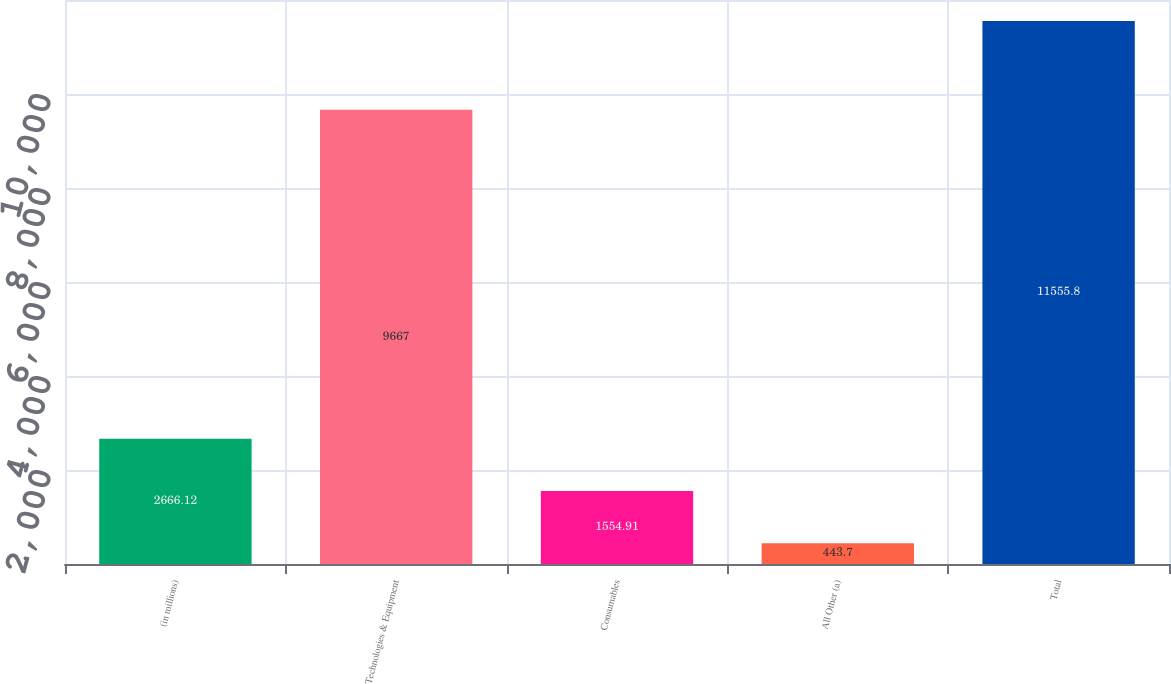<chart> <loc_0><loc_0><loc_500><loc_500><bar_chart><fcel>(in millions)<fcel>Technologies & Equipment<fcel>Consumables<fcel>All Other (a)<fcel>Total<nl><fcel>2666.12<fcel>9667<fcel>1554.91<fcel>443.7<fcel>11555.8<nl></chart> 